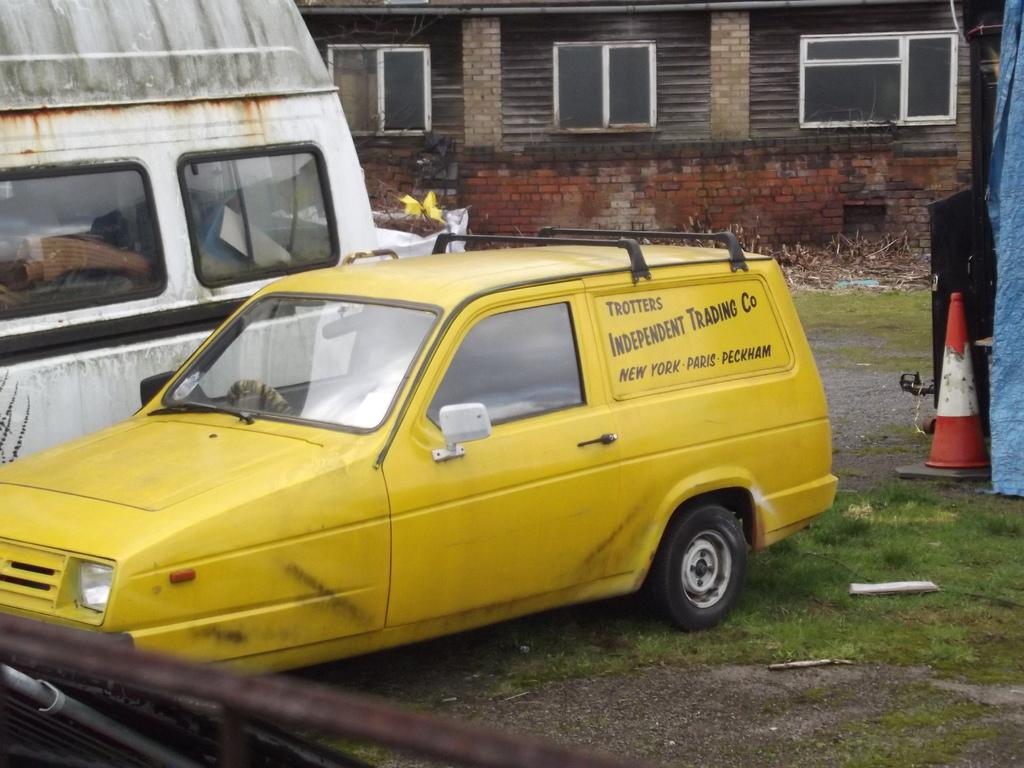<image>
Write a terse but informative summary of the picture. The traders who own this yellow van trade in New York, Paris and Peckham. 